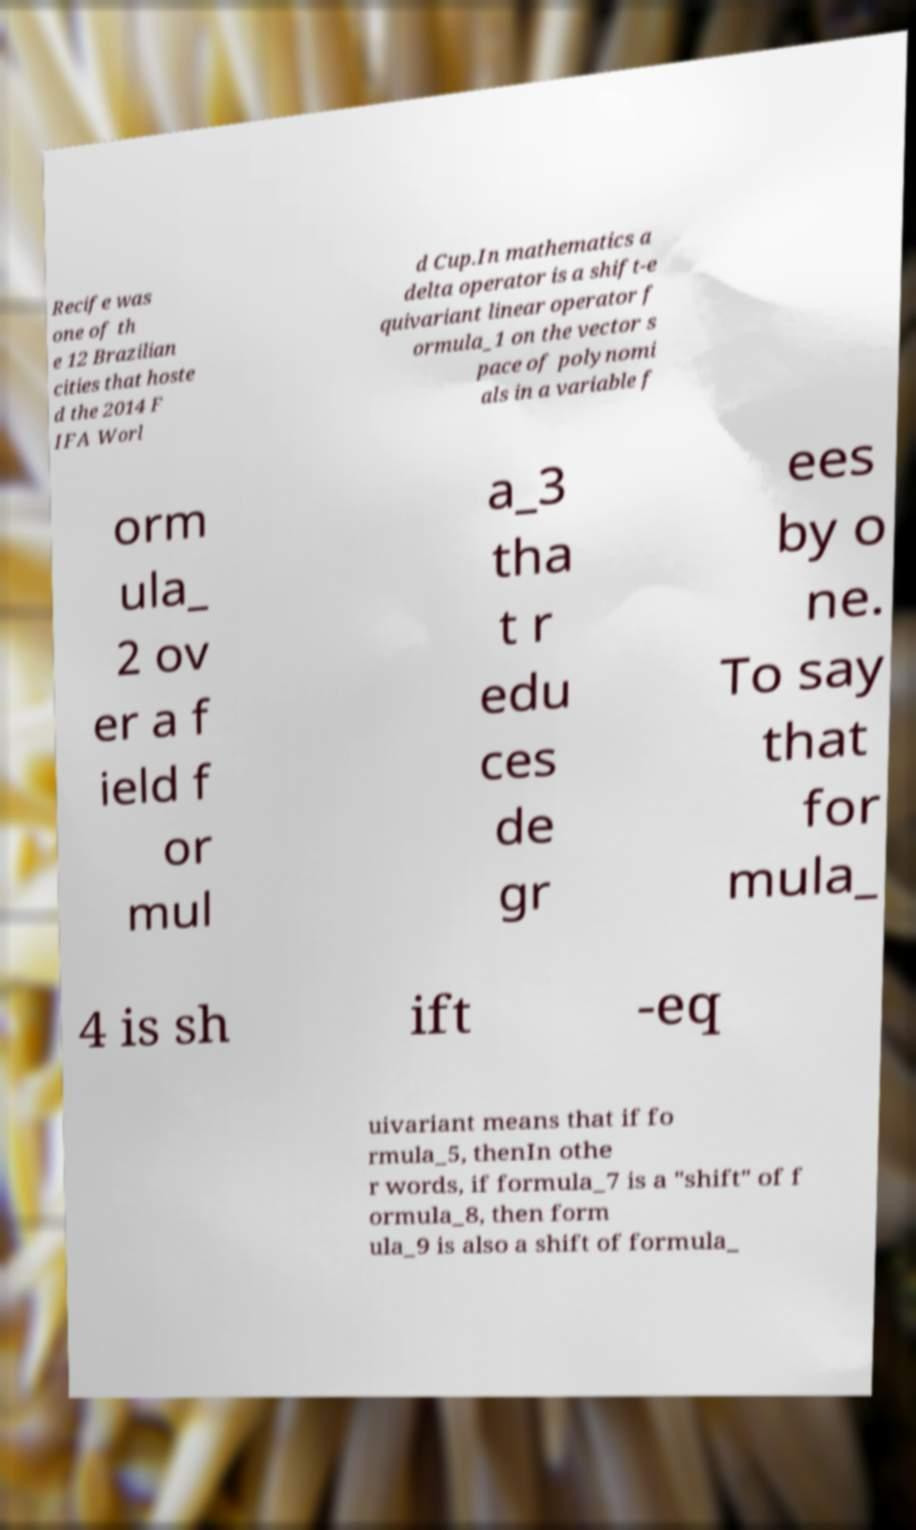Can you accurately transcribe the text from the provided image for me? Recife was one of th e 12 Brazilian cities that hoste d the 2014 F IFA Worl d Cup.In mathematics a delta operator is a shift-e quivariant linear operator f ormula_1 on the vector s pace of polynomi als in a variable f orm ula_ 2 ov er a f ield f or mul a_3 tha t r edu ces de gr ees by o ne. To say that for mula_ 4 is sh ift -eq uivariant means that if fo rmula_5, thenIn othe r words, if formula_7 is a "shift" of f ormula_8, then form ula_9 is also a shift of formula_ 